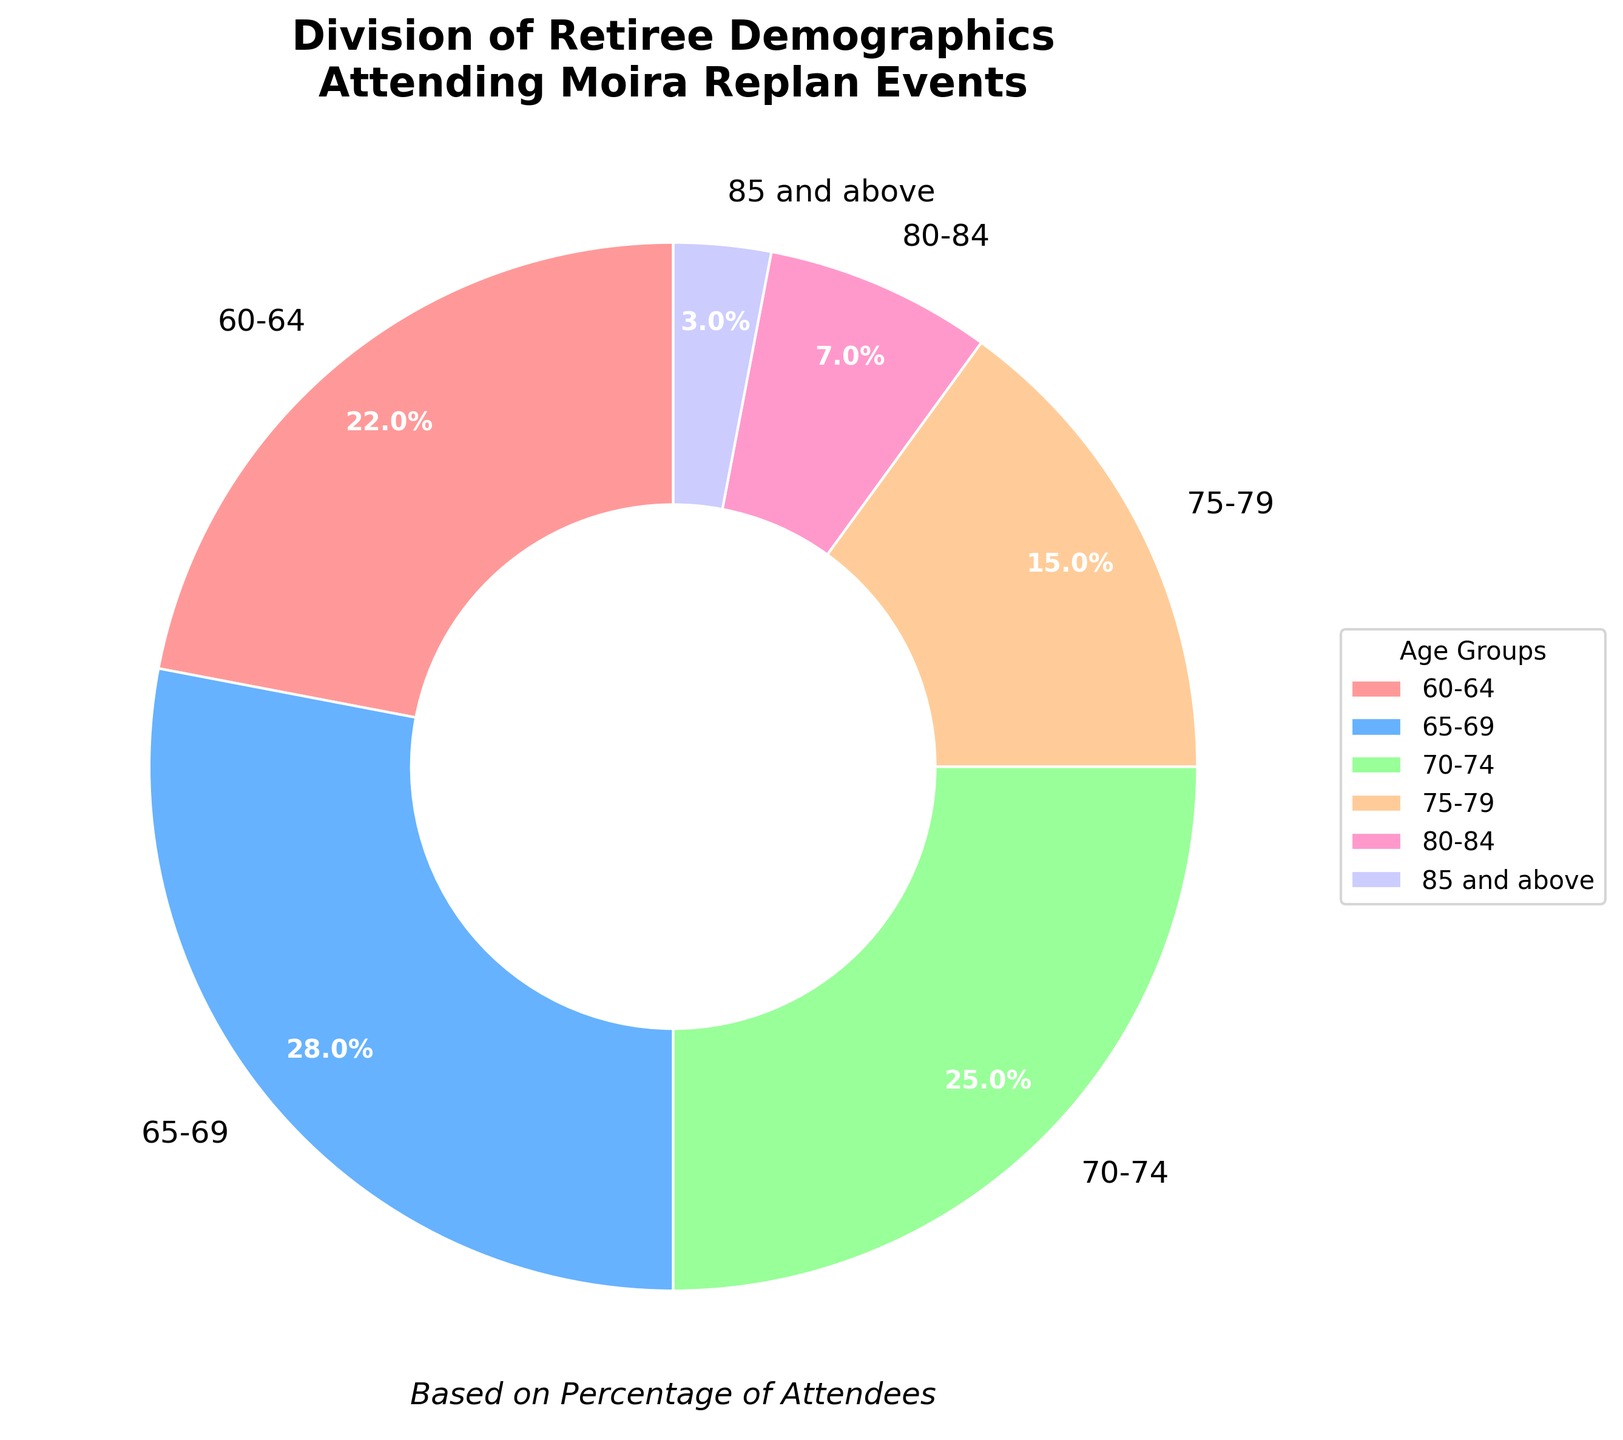What is the largest age group attending Moira Replan events? Look at the pie chart and identify the segment with the largest percentage. The "65-69" group has the highest percentage at 28%.
Answer: 65-69 Which two age groups have the smallest combined percentage of participants? First, find the smallest percentages from the chart: "85 and above" (3%) and "80-84" (7%). Add these to get 3% + 7% = 10%.
Answer: 85 and above, 80-84 How much greater is the percentage of attendees aged 65-69 compared to those aged 60-64? Subtract the percentage of the 60-64 age group from the 65-69 age group: 28% - 22% = 6%.
Answer: 6% What is the difference between the sum of the percentages of the two oldest and two youngest age groups? Add the percentages of the two oldest groups: "85 and above" (3%) and "80-84" (7%) = 10%. Add the percentages of the two youngest groups: "60-64" (22%) and "65-69" (28%) = 50%. Subtract these sums: 50% - 10% = 40%.
Answer: 40% Which age group is represented by the light green color in the pie chart? Compare the colors in the pie chart with the legend to identify the light green segment, which represents the "70-74" age group.
Answer: 70-74 What proportion of attendees are 75 or older? Add the percentages for age groups "75-79" (15%), "80-84" (7%), and "85 and above" (3%): 15% + 7% + 3% = 25%.
Answer: 25% What is the difference in percentage points between the age group with the second highest attendance and the one with the second lowest attendance? Identify the second highest percentage (70-74 at 25%) and second lowest (80-84 at 7%), then subtract: 25% - 7% = 18%.
Answer: 18% By how much does the percentage of participants aged 70-74 exceed those aged 80-84? Subtract the percentage of the 80-84 group from the 70-74 group: 25% - 7% = 18%.
Answer: 18% What is the total percentage of attendees aged between 60 and 74? Add the percentages for the age groups "60-64" (22%), "65-69" (28%), and "70-74" (25%): 22% + 28% + 25% = 75%.
Answer: 75% If the age groups 60-64 and 85 and above were combined into one group, what would be the percentage of this new group? Add the percentages of the "60-64" (22%) and "85 and above" (3%) groups: 22% + 3% = 25%.
Answer: 25% 